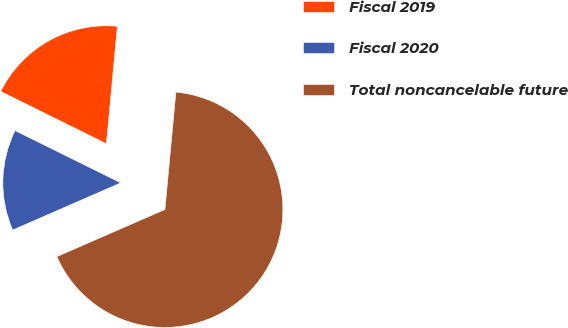Convert chart to OTSL. <chart><loc_0><loc_0><loc_500><loc_500><pie_chart><fcel>Fiscal 2019<fcel>Fiscal 2020<fcel>Total noncancelable future<nl><fcel>19.17%<fcel>13.86%<fcel>66.98%<nl></chart> 